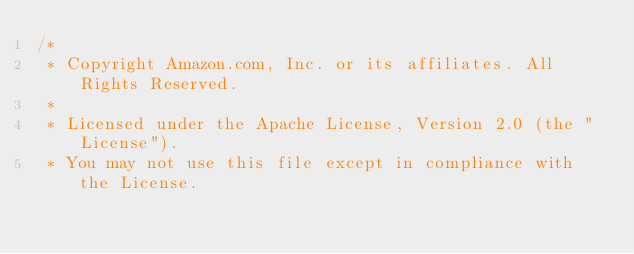<code> <loc_0><loc_0><loc_500><loc_500><_C#_>/*
 * Copyright Amazon.com, Inc. or its affiliates. All Rights Reserved.
 * 
 * Licensed under the Apache License, Version 2.0 (the "License").
 * You may not use this file except in compliance with the License.</code> 